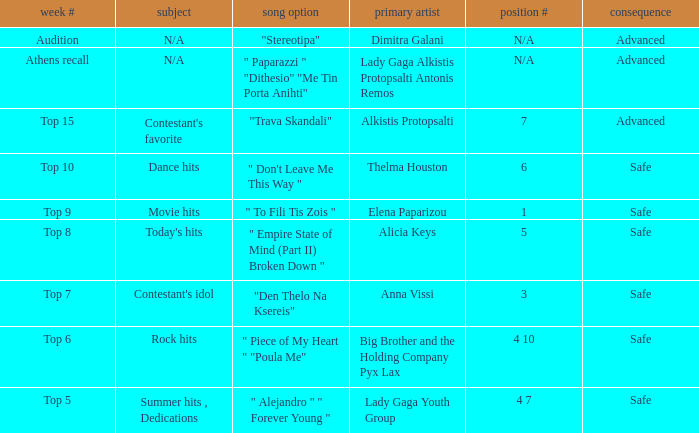During the audition week, which song was selected? "Stereotipa". 